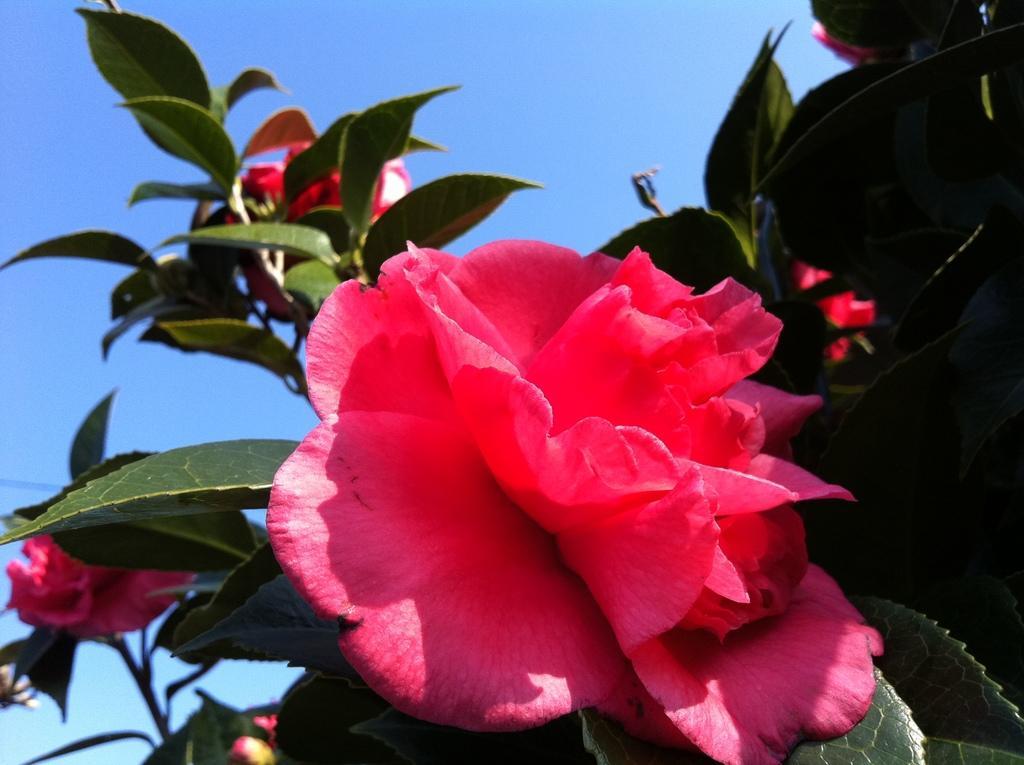How would you summarize this image in a sentence or two? In this image we can see some flowers to a plant. On the backside we can see the sky which looks cloudy. 